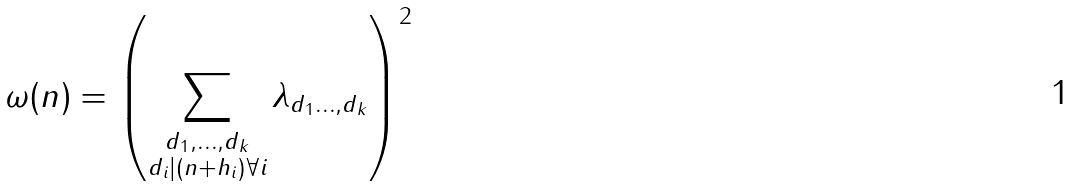Convert formula to latex. <formula><loc_0><loc_0><loc_500><loc_500>\omega ( n ) = \left ( \sum _ { \substack { d _ { 1 } , \dots , d _ { k } \\ d _ { i } | ( n + h _ { i } ) \forall i } } \lambda _ { d _ { 1 } \dots , d _ { k } } \right ) ^ { 2 }</formula> 